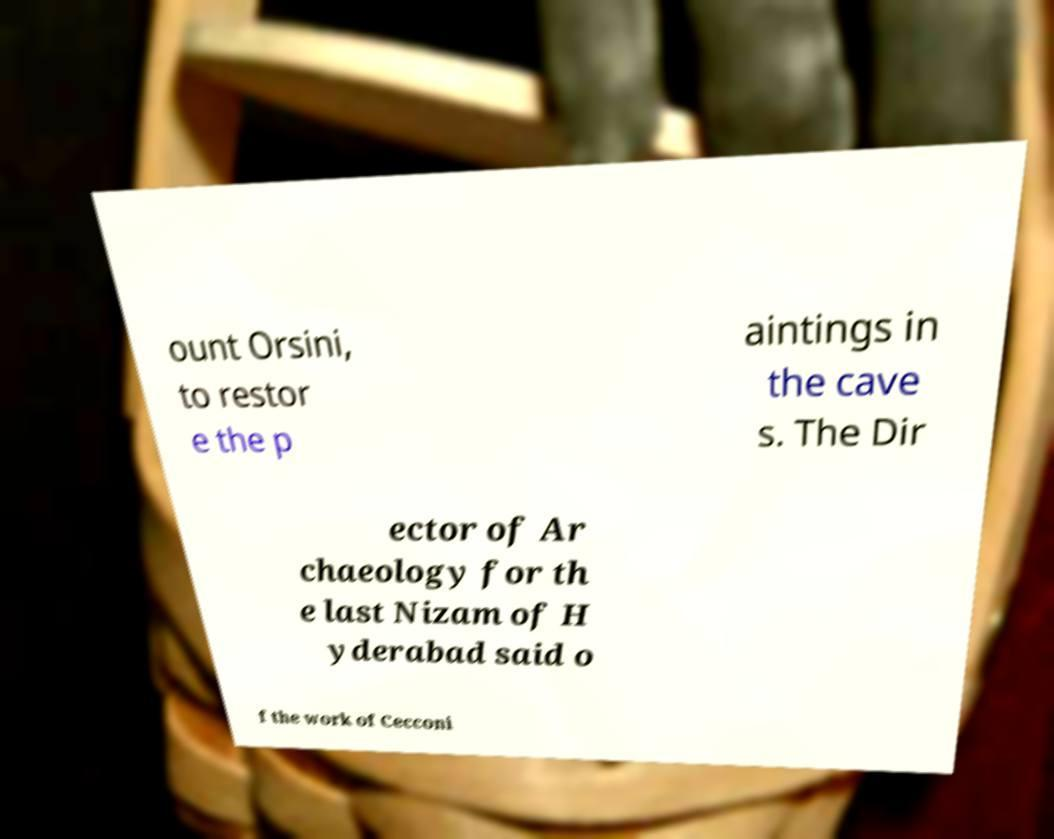What messages or text are displayed in this image? I need them in a readable, typed format. ount Orsini, to restor e the p aintings in the cave s. The Dir ector of Ar chaeology for th e last Nizam of H yderabad said o f the work of Cecconi 